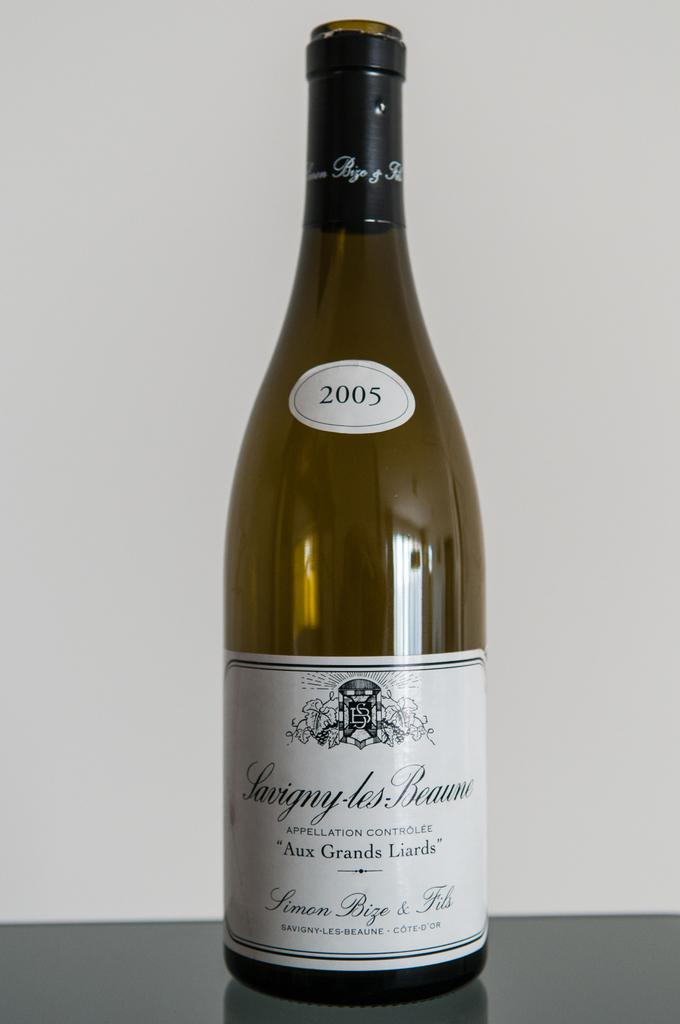Provide a one-sentence caption for the provided image. A bottle of French wine with a sticker of the year 2005 labeled on it. 